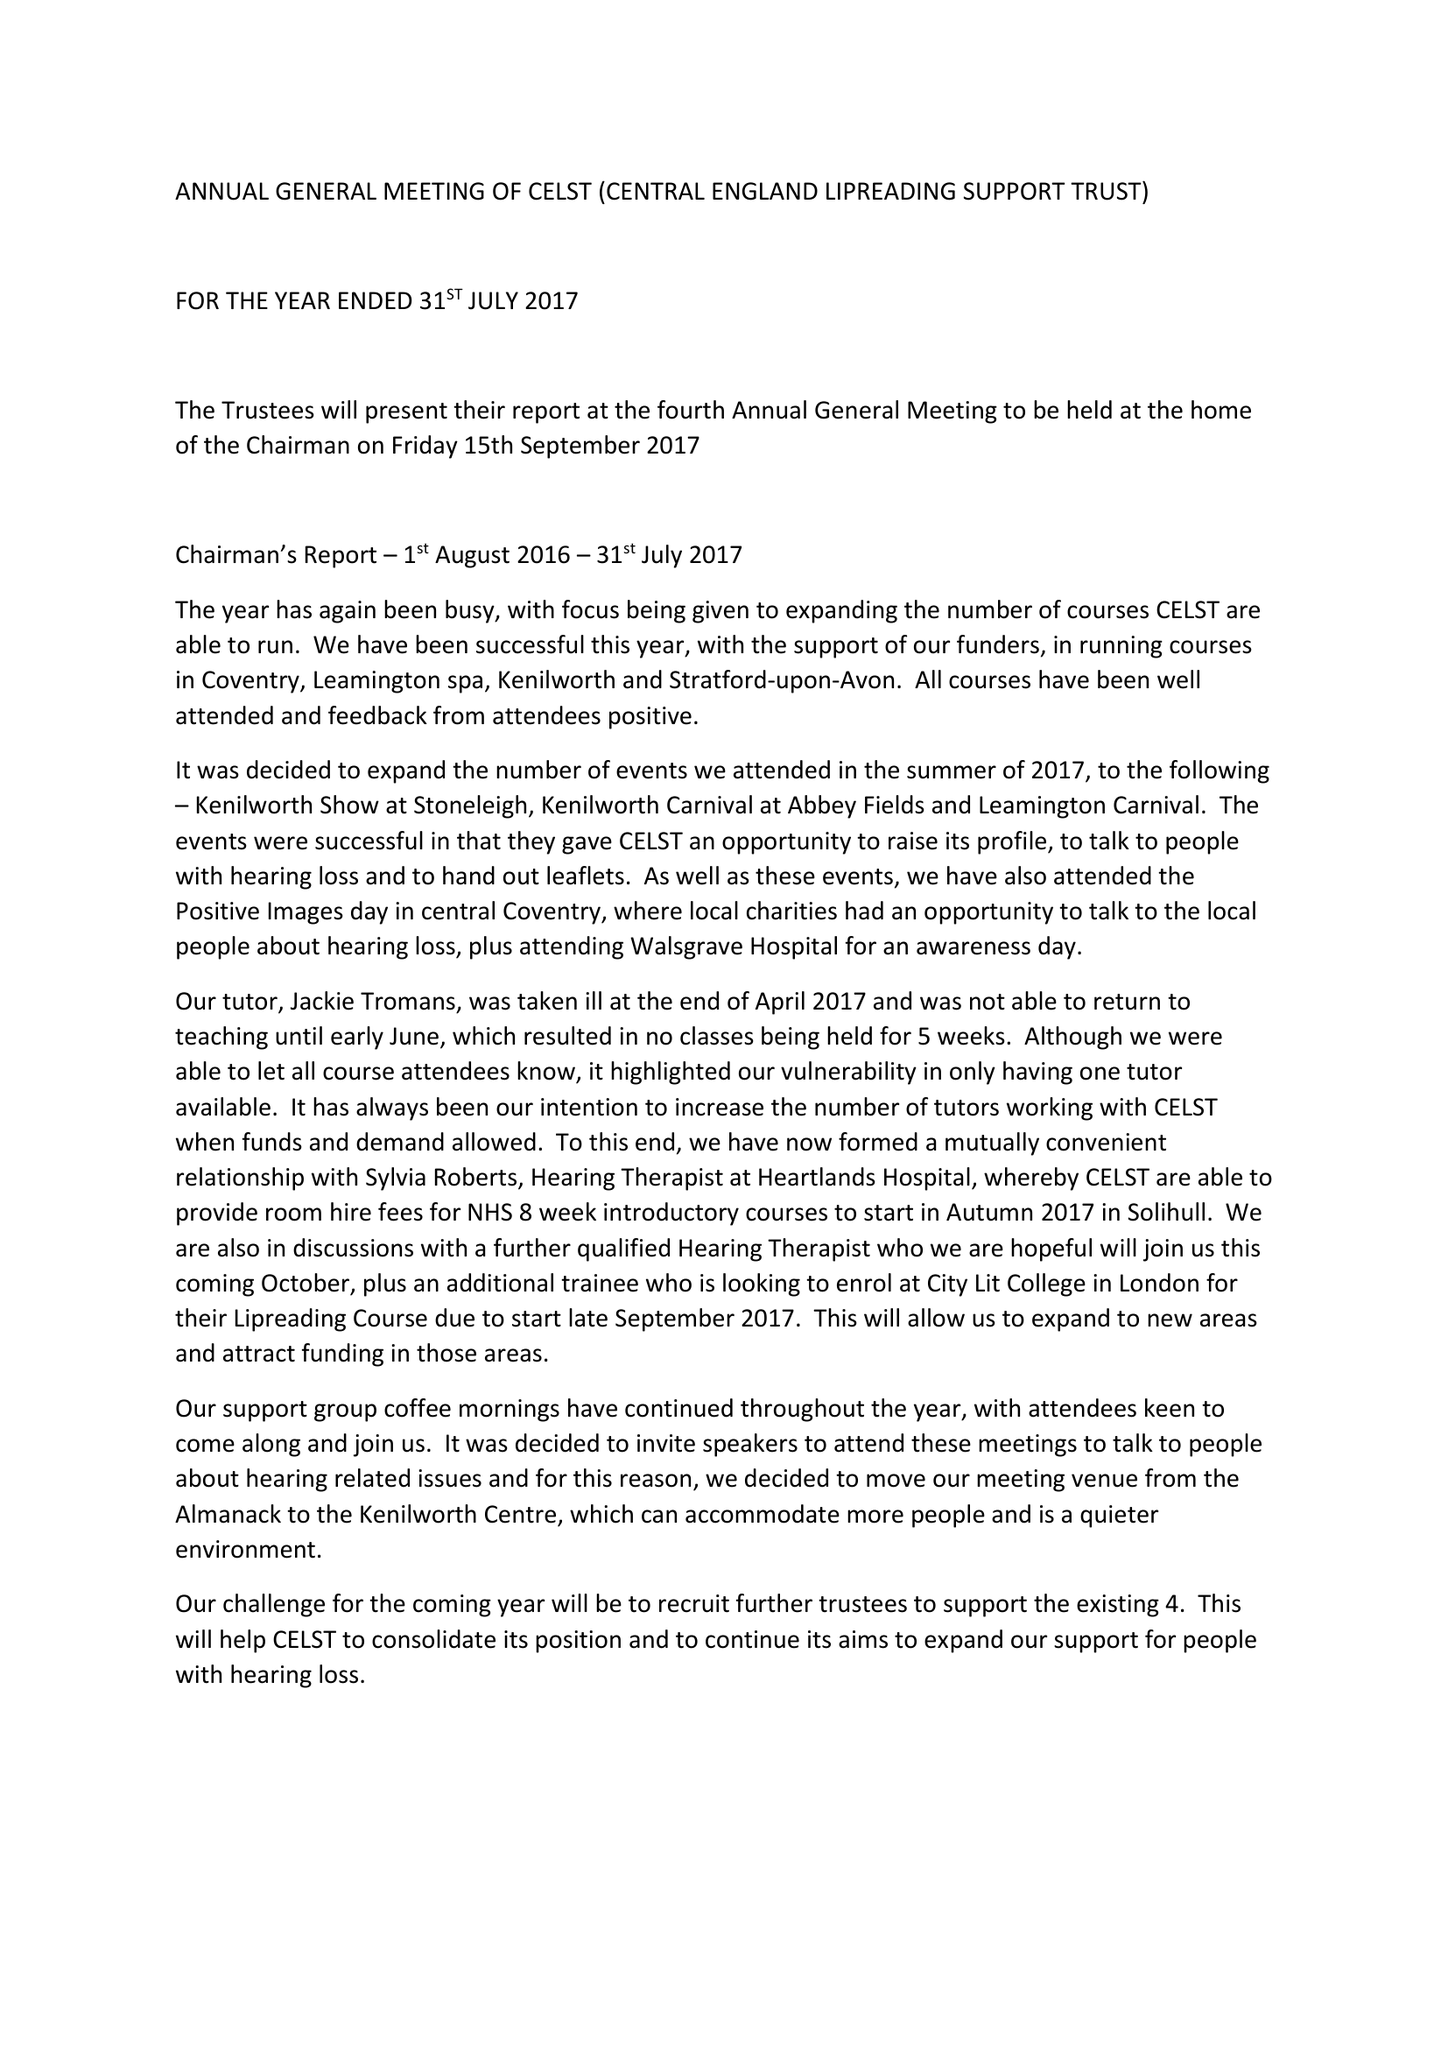What is the value for the address__street_line?
Answer the question using a single word or phrase. 13 JORDAN CLOSE 